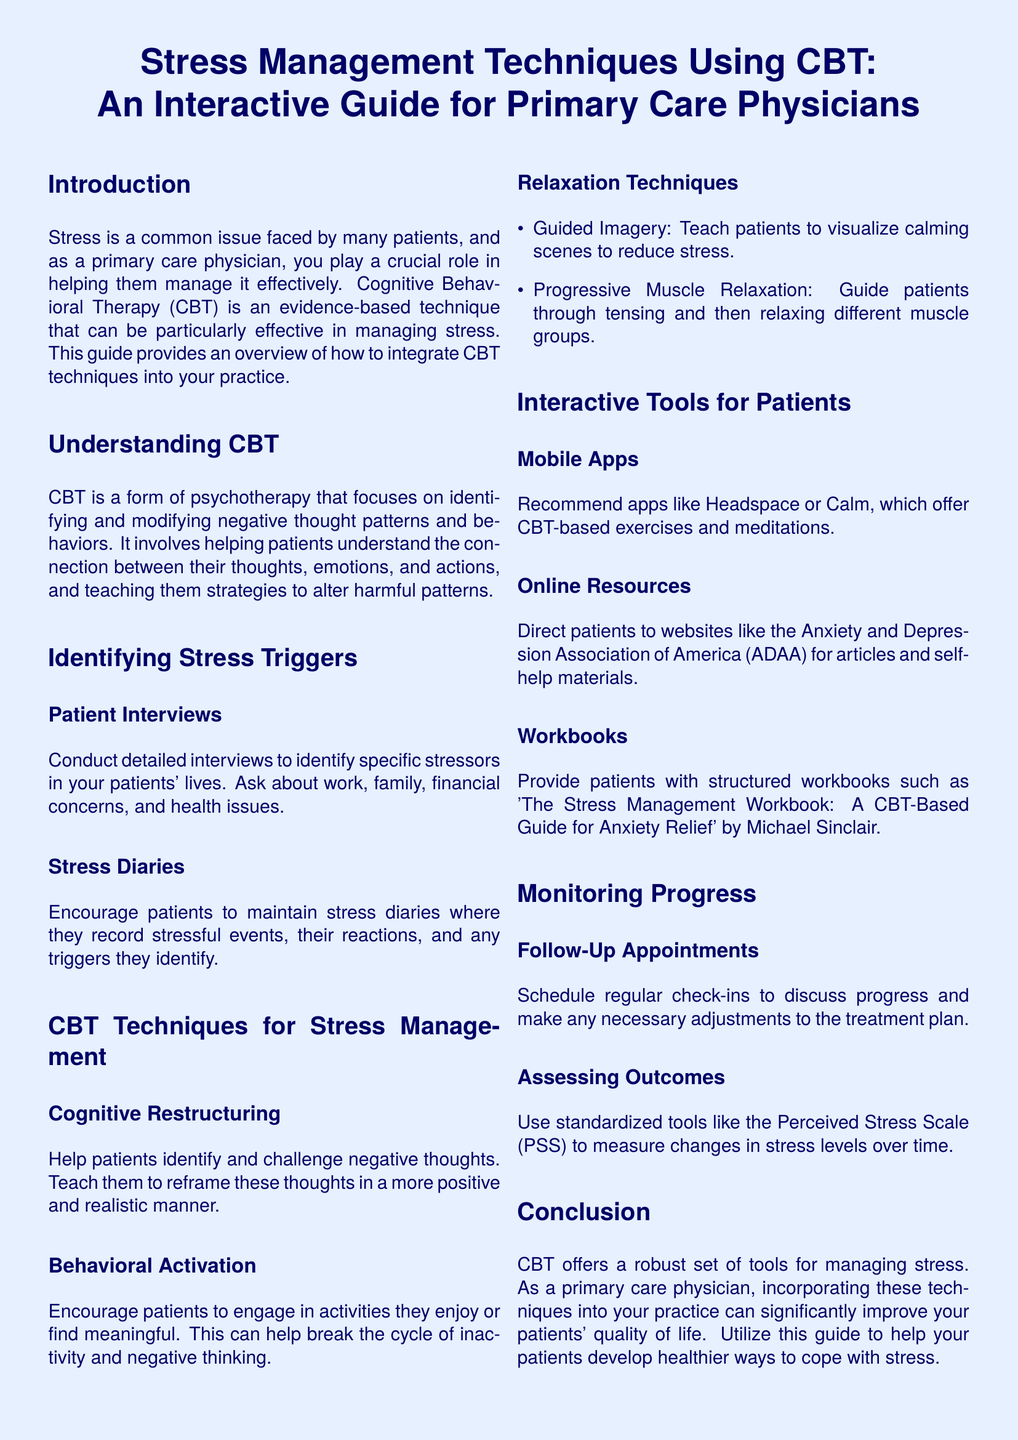what is the primary focus of CBT? CBT focuses on identifying and modifying negative thought patterns and behaviors.
Answer: identifying and modifying negative thought patterns and behaviors what are two examples of relaxation techniques mentioned? The document lists guided imagery and progressive muscle relaxation as relaxation techniques.
Answer: guided imagery, progressive muscle relaxation what is the purpose of stress diaries? Stress diaries are meant for patients to record stressful events and their reactions, helping to identify triggers.
Answer: identify triggers what does the acronym PSS stand for? PSS stands for Perceived Stress Scale, a tool mentioned for assessing outcomes.
Answer: Perceived Stress Scale which mobile apps are recommended in the guide? The guide recommends apps like Headspace and Calm for CBT-based exercises.
Answer: Headspace, Calm how should follow-up appointments be used? Follow-up appointments are used to schedule regular check-ins to discuss progress and make adjustments.
Answer: discuss progress what is the title of the workbook provided as a resource? The stress management workbook is titled "The Stress Management Workbook: A CBT-Based Guide for Anxiety Relief."
Answer: The Stress Management Workbook: A CBT-Based Guide for Anxiety Relief which section helps in identifying stress triggers? The section titled "Identifying Stress Triggers" guides physicians on how to find stressors in patients' lives.
Answer: Identifying Stress Triggers 